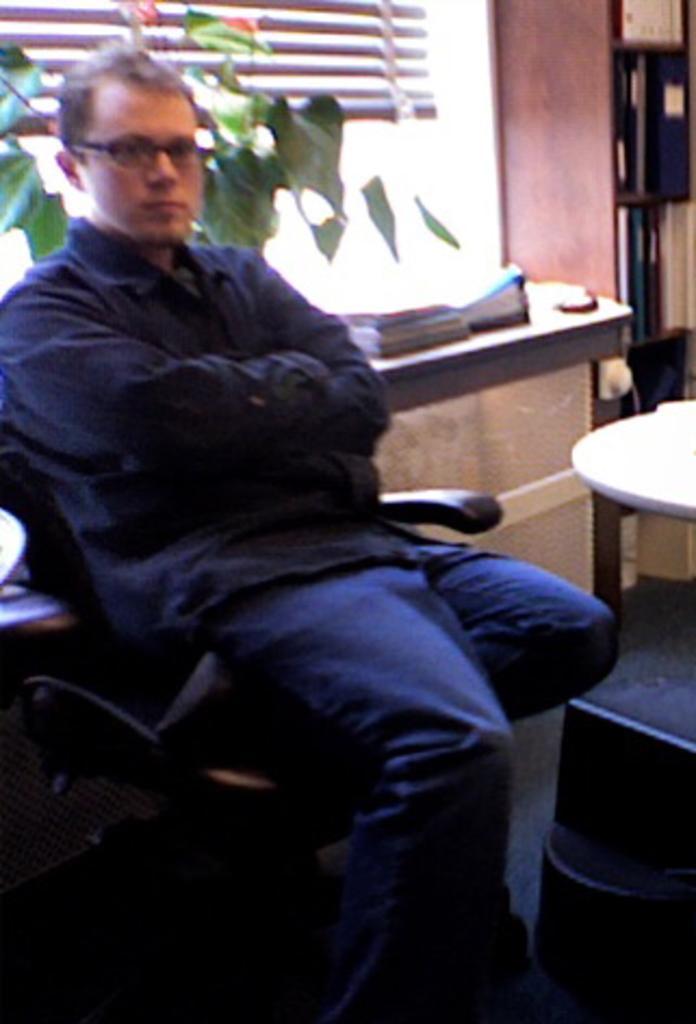Please provide a concise description of this image. In this image I can see the person sitting on the chair. To the right I can see the table. In the back there is a plant and some books on the table. I can also see the windows in the back. 